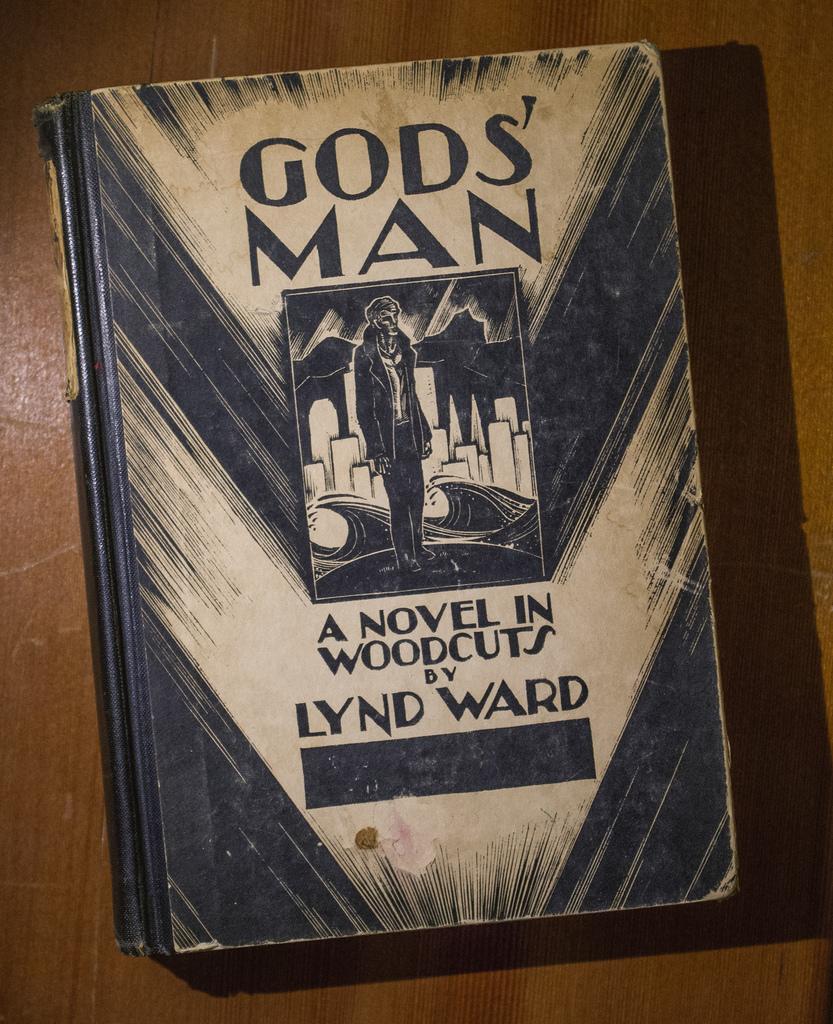What is the name of the book?
Provide a short and direct response. God's man. Who wrote this book?
Keep it short and to the point. Lynd ward. 